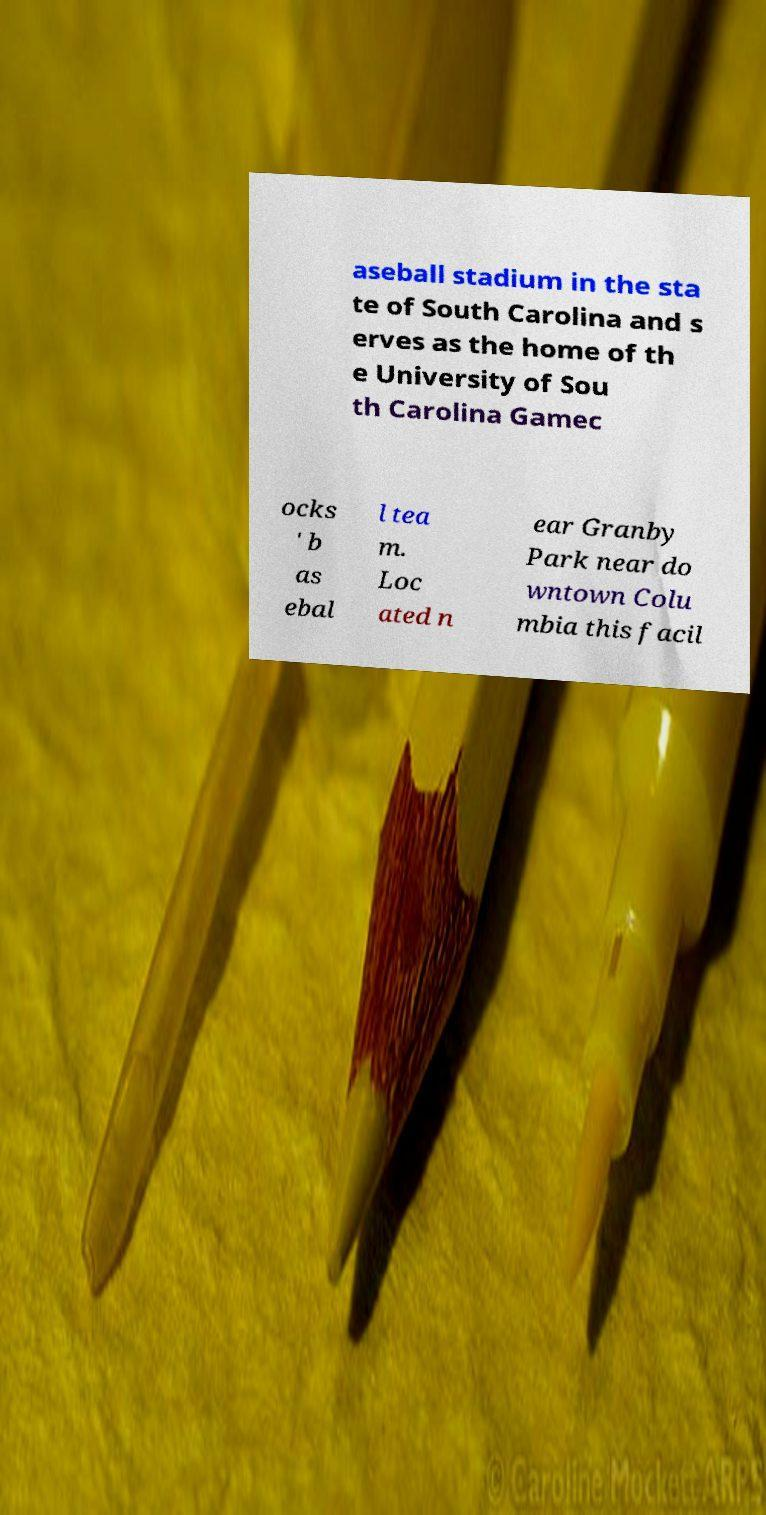Please read and relay the text visible in this image. What does it say? aseball stadium in the sta te of South Carolina and s erves as the home of th e University of Sou th Carolina Gamec ocks ' b as ebal l tea m. Loc ated n ear Granby Park near do wntown Colu mbia this facil 